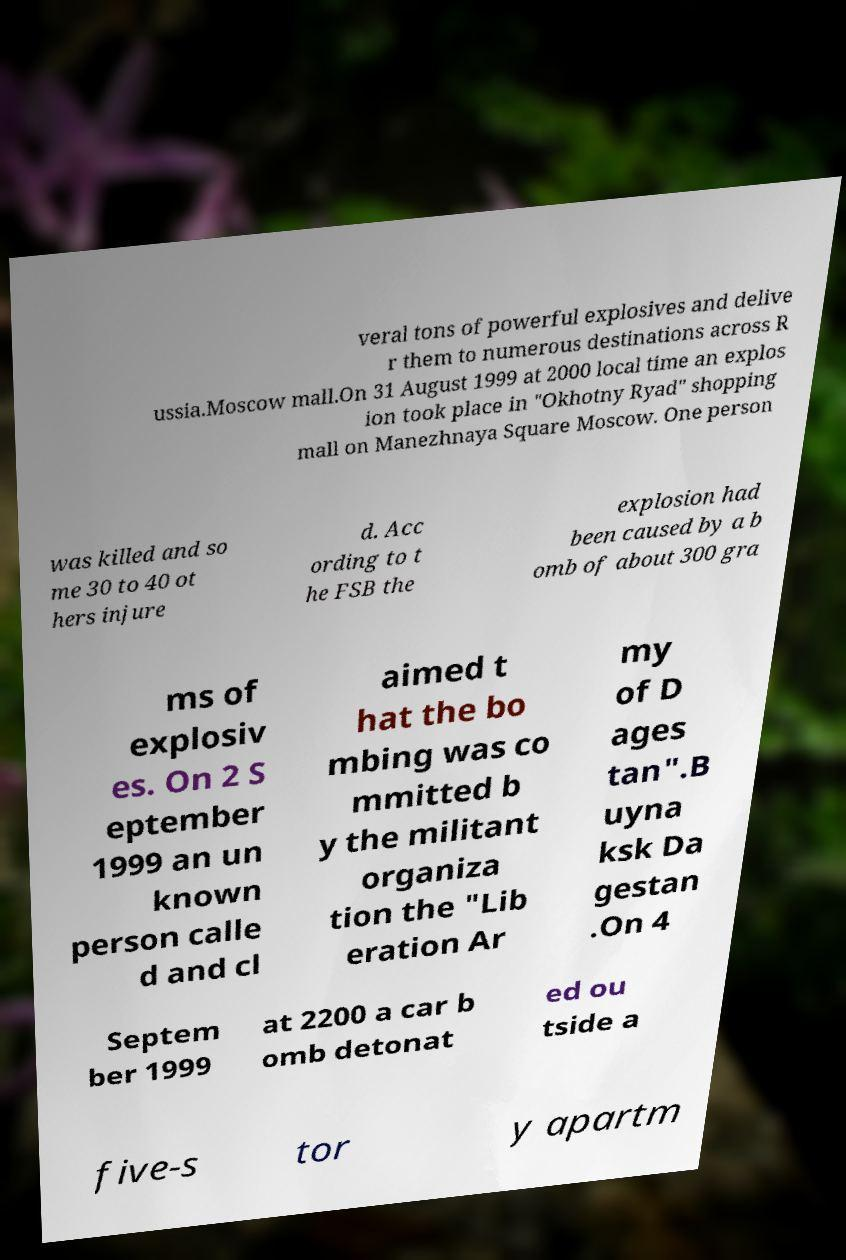Could you assist in decoding the text presented in this image and type it out clearly? veral tons of powerful explosives and delive r them to numerous destinations across R ussia.Moscow mall.On 31 August 1999 at 2000 local time an explos ion took place in "Okhotny Ryad" shopping mall on Manezhnaya Square Moscow. One person was killed and so me 30 to 40 ot hers injure d. Acc ording to t he FSB the explosion had been caused by a b omb of about 300 gra ms of explosiv es. On 2 S eptember 1999 an un known person calle d and cl aimed t hat the bo mbing was co mmitted b y the militant organiza tion the "Lib eration Ar my of D ages tan".B uyna ksk Da gestan .On 4 Septem ber 1999 at 2200 a car b omb detonat ed ou tside a five-s tor y apartm 